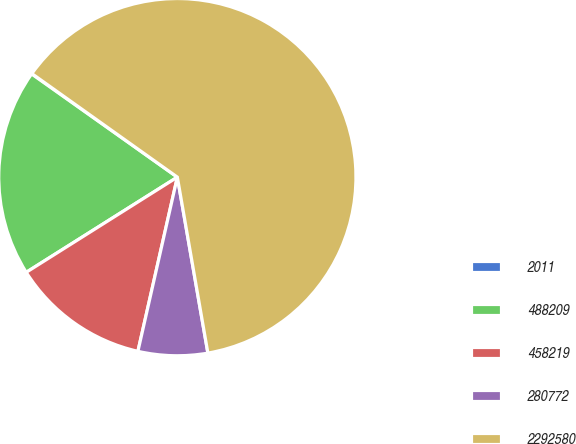Convert chart to OTSL. <chart><loc_0><loc_0><loc_500><loc_500><pie_chart><fcel>2011<fcel>488209<fcel>458219<fcel>280772<fcel>2292580<nl><fcel>0.04%<fcel>18.75%<fcel>12.51%<fcel>6.28%<fcel>62.42%<nl></chart> 